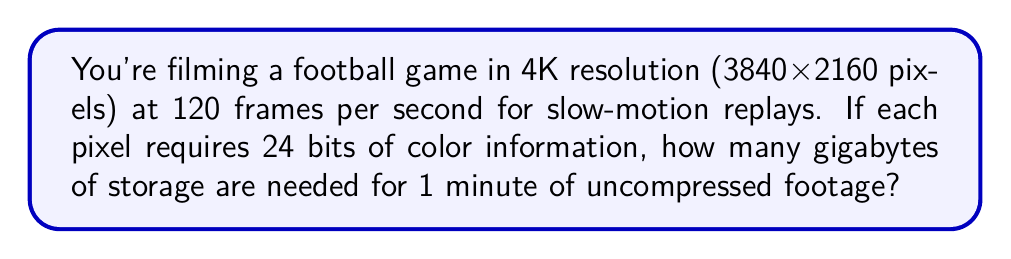Give your solution to this math problem. Let's break this down step-by-step:

1. Calculate the number of pixels per frame:
   $3840 \times 2160 = 8,294,400$ pixels

2. Calculate the number of bits per frame:
   $8,294,400 \text{ pixels} \times 24 \text{ bits/pixel} = 199,065,600 \text{ bits}$

3. Convert bits to bytes:
   $199,065,600 \text{ bits} \div 8 \text{ bits/byte} = 24,883,200 \text{ bytes}$

4. Calculate the number of frames in 1 minute:
   $120 \text{ frames/second} \times 60 \text{ seconds} = 7,200 \text{ frames}$

5. Calculate the total number of bytes for 1 minute:
   $24,883,200 \text{ bytes/frame} \times 7,200 \text{ frames} = 179,159,040,000 \text{ bytes}$

6. Convert bytes to gigabytes:
   $$\frac{179,159,040,000 \text{ bytes}}{1,073,741,824 \text{ bytes/GB}} \approx 166.85 \text{ GB}$$
Answer: 166.85 GB 